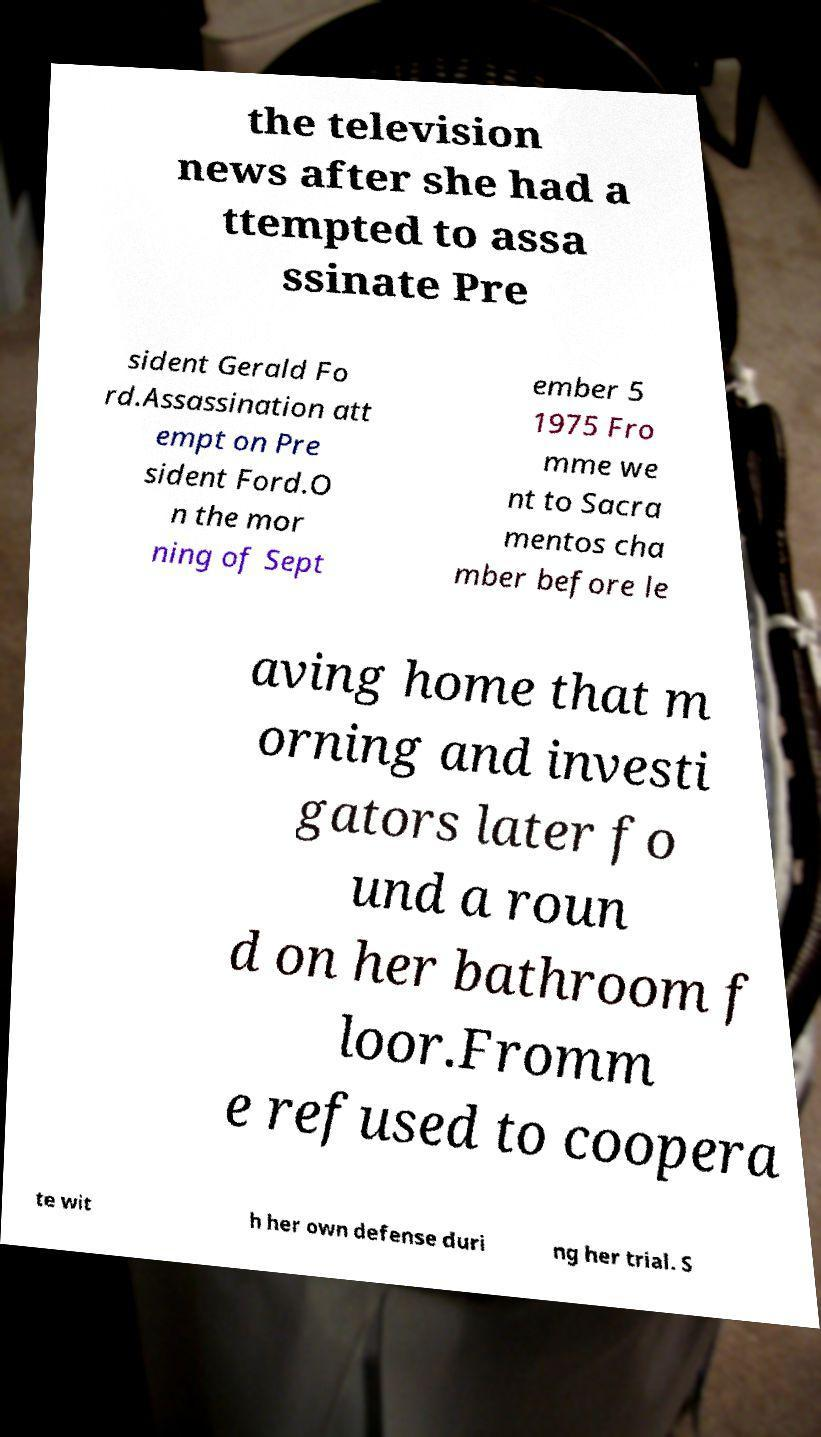Please identify and transcribe the text found in this image. the television news after she had a ttempted to assa ssinate Pre sident Gerald Fo rd.Assassination att empt on Pre sident Ford.O n the mor ning of Sept ember 5 1975 Fro mme we nt to Sacra mentos cha mber before le aving home that m orning and investi gators later fo und a roun d on her bathroom f loor.Fromm e refused to coopera te wit h her own defense duri ng her trial. S 